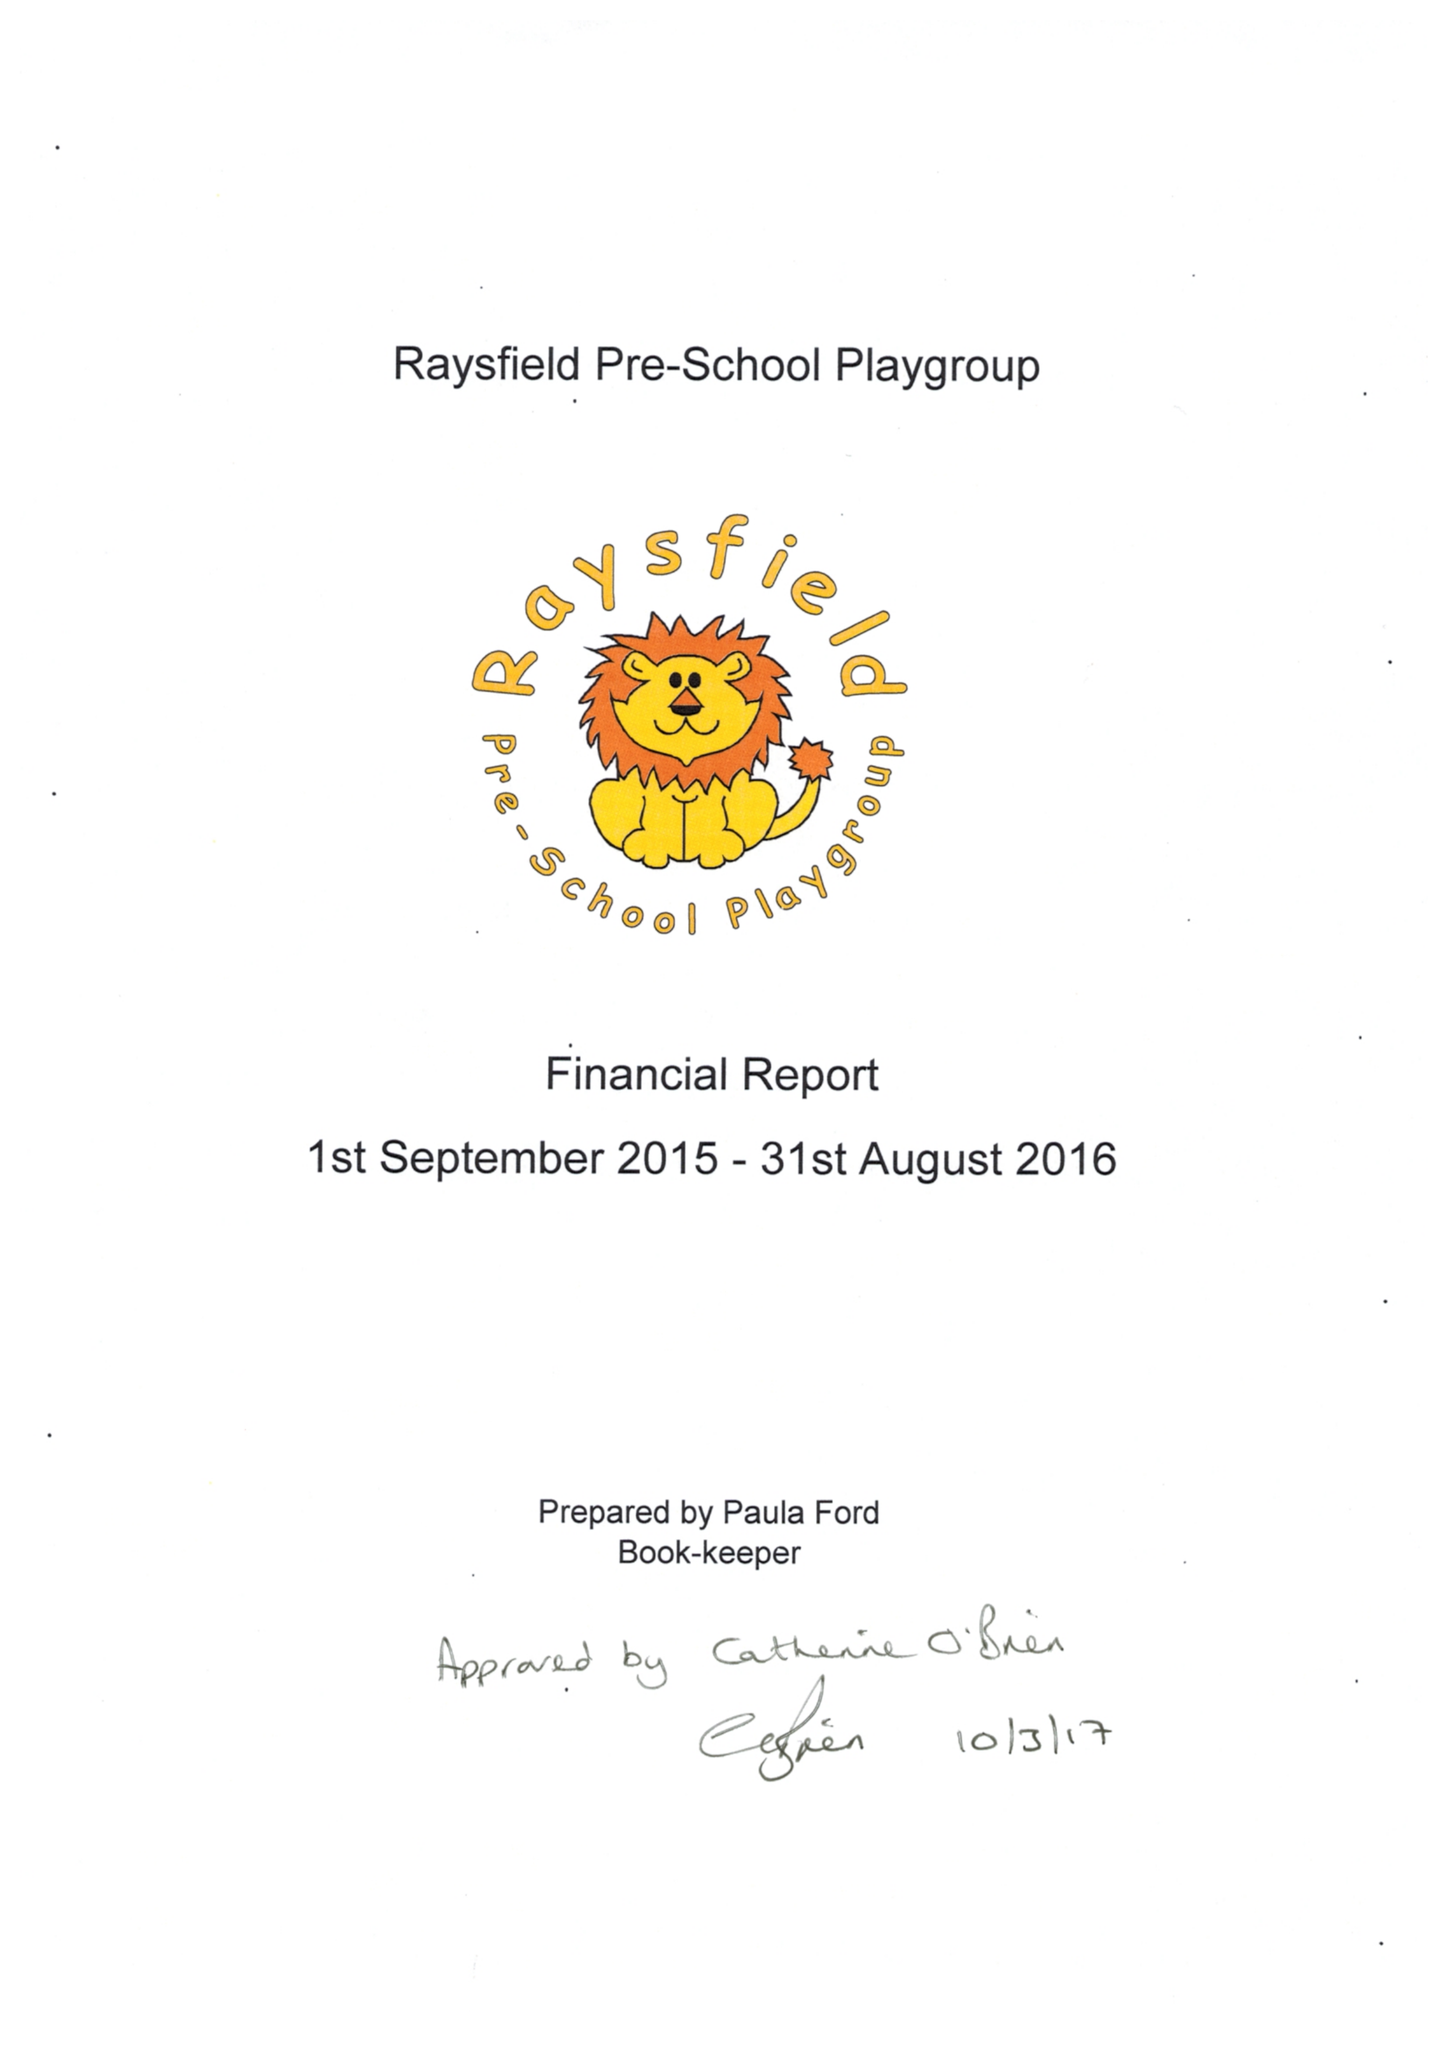What is the value for the address__post_town?
Answer the question using a single word or phrase. BRISTOL 